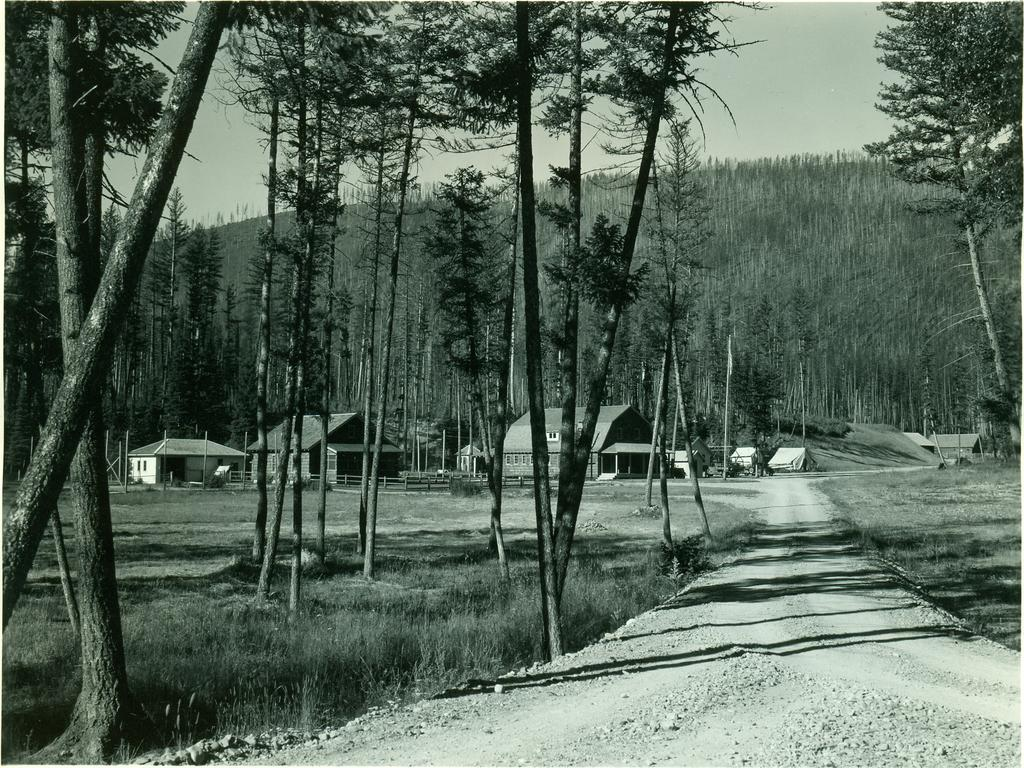What can be seen in the foreground of the image? There is a path in the foreground of the image. What is located on the right side of the image? There are trees on the right side of the image. What type of structures can be seen in the background of the image? There are houses in the background of the image. What is the natural feature visible in the background of the image? There are trees on a mountain in the background of the image. What is visible above the houses and trees in the image? The sky is visible in the background of the image. What type of paste is being used on the trees in the image? There is no mention of paste in the image. --- Facts: 1. There is a person in the image. 2. The person is wearing a hat. 3. The person is holding a book. 4. The person is standing in front of a bookshelf. 5. The bookshelf is filled with books. Absurd Topics: elephant, piano, ocean Conversation: What can be seen in the image? There is a person in the image. What is the person wearing in the image? The person is wearing a hat. What is the person holding in the image? The person is holding a book. What is the person standing in front of in the image? The person is standing in front of a bookshelf. What can be observed about the bookshelf in the image? The bookshelf is filled with books. Reasoning: Let's think step by step in order to produce the conversation. We start by identifying the main subject of the image, which is the person. Next, we describe specific features of the person, such as the hat and the book they are holding. Then, we observe the person's location in relation to the bookshelf. Finally, we describe the bookshelf's condition, which is filled with books. Absurd Question/Answer: What type of elephant can be seen playing the piano in the image? There is no mention of an elephant or a piano in the image. 